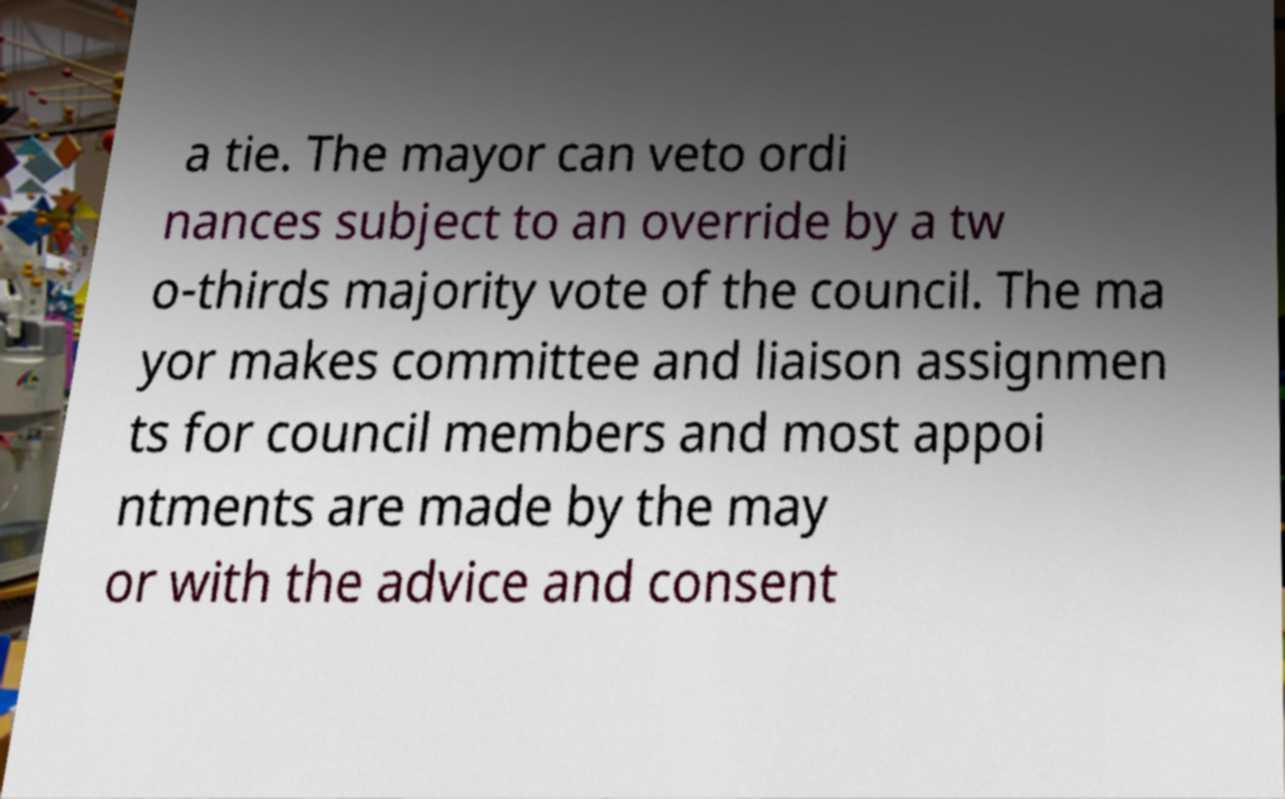There's text embedded in this image that I need extracted. Can you transcribe it verbatim? a tie. The mayor can veto ordi nances subject to an override by a tw o-thirds majority vote of the council. The ma yor makes committee and liaison assignmen ts for council members and most appoi ntments are made by the may or with the advice and consent 